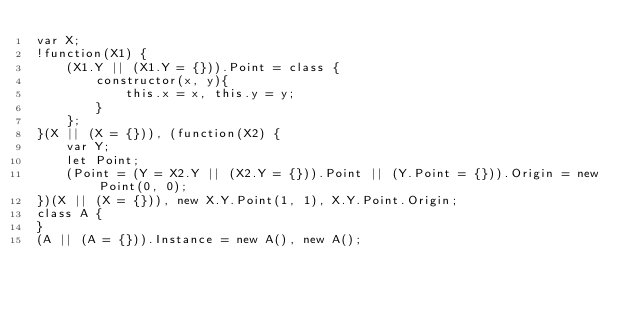<code> <loc_0><loc_0><loc_500><loc_500><_JavaScript_>var X;
!function(X1) {
    (X1.Y || (X1.Y = {})).Point = class {
        constructor(x, y){
            this.x = x, this.y = y;
        }
    };
}(X || (X = {})), (function(X2) {
    var Y;
    let Point;
    (Point = (Y = X2.Y || (X2.Y = {})).Point || (Y.Point = {})).Origin = new Point(0, 0);
})(X || (X = {})), new X.Y.Point(1, 1), X.Y.Point.Origin;
class A {
}
(A || (A = {})).Instance = new A(), new A();
</code> 